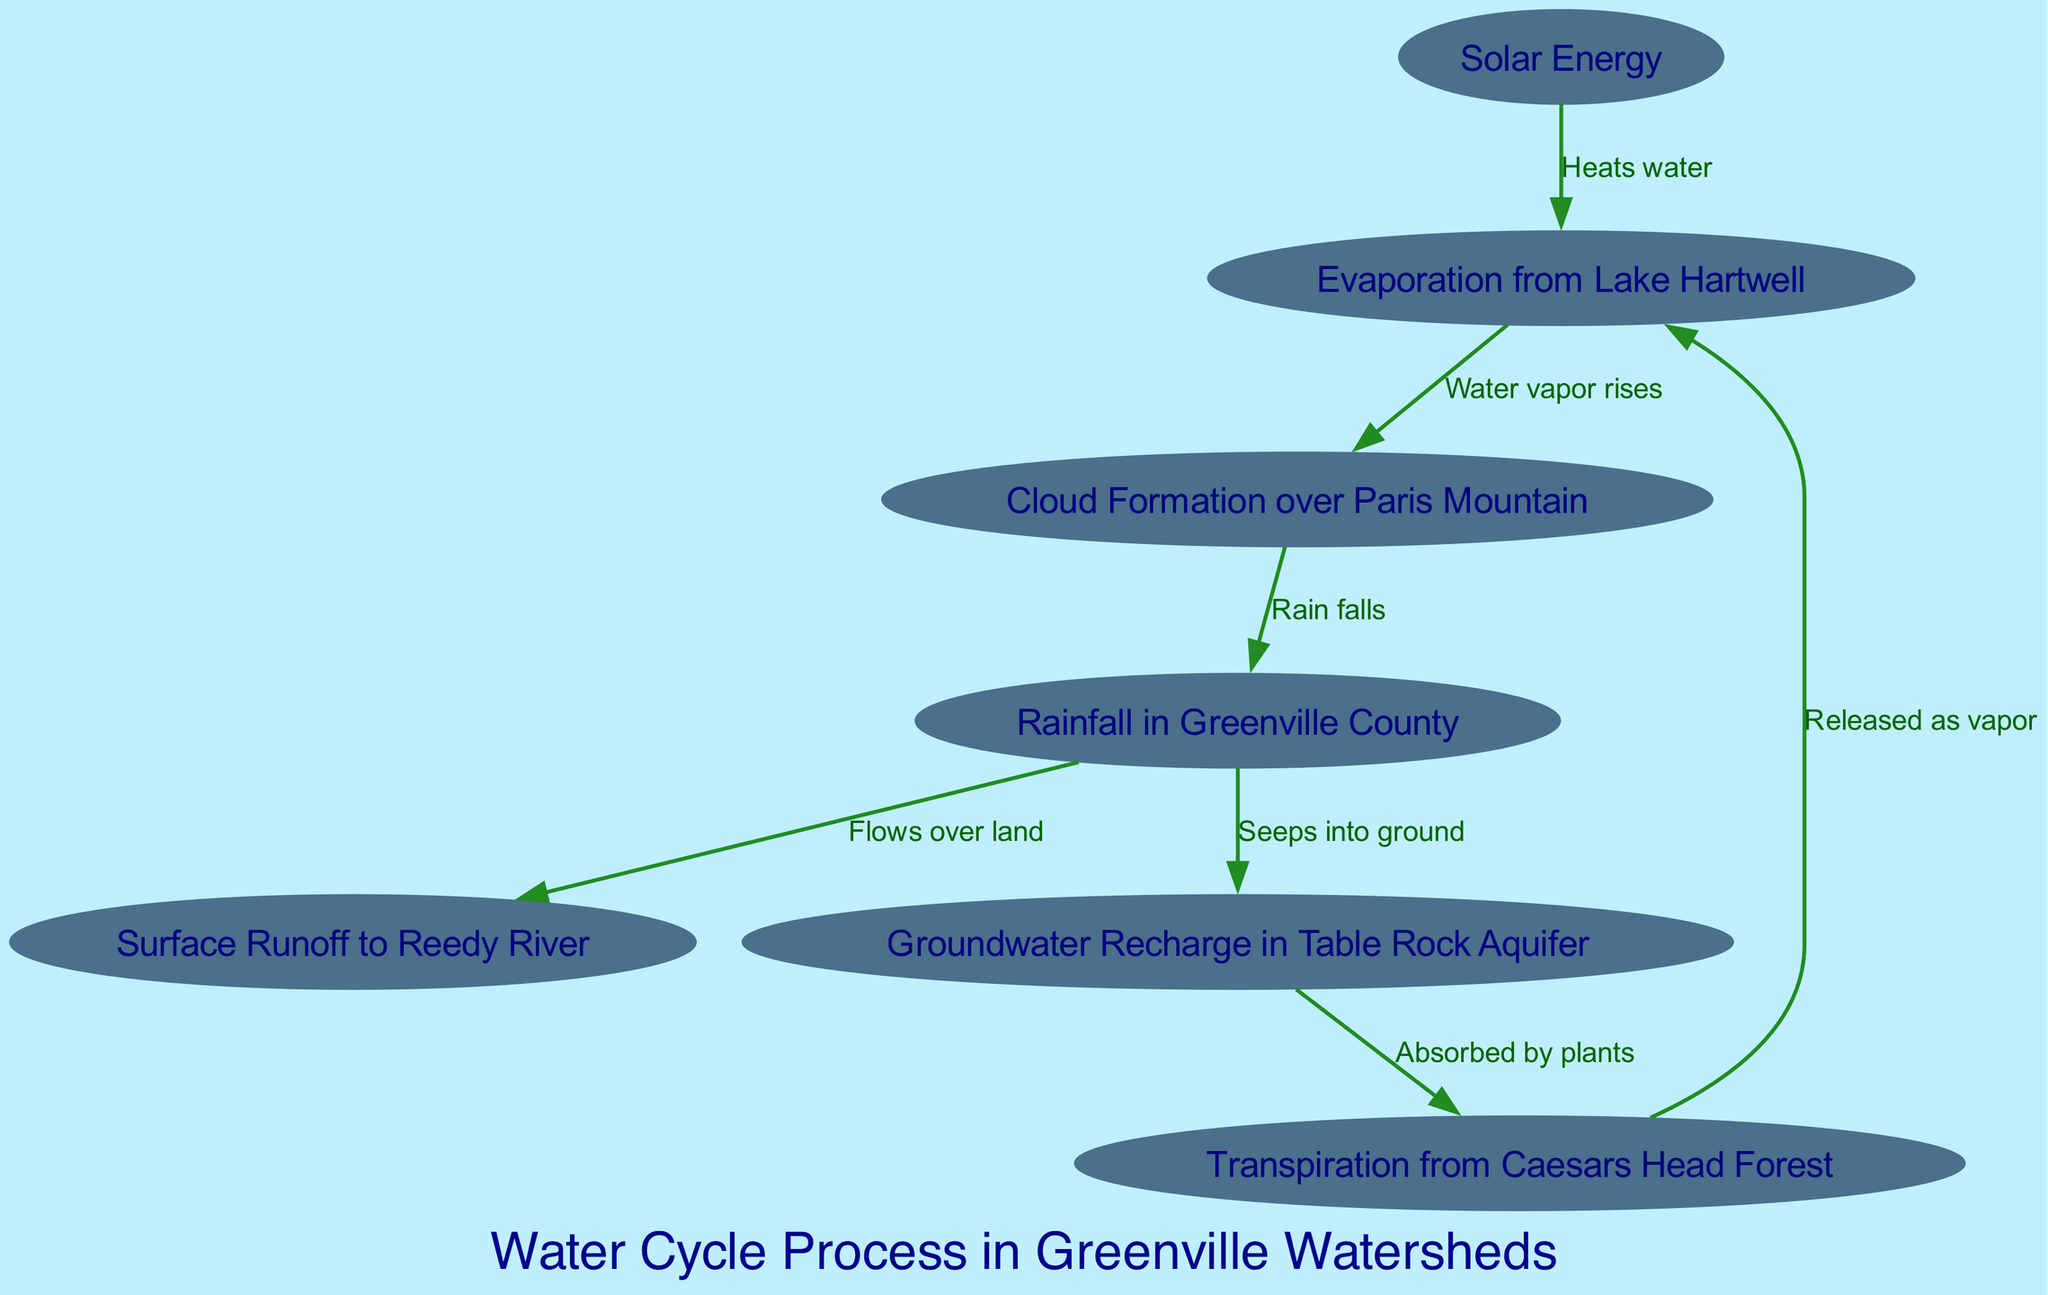What is the first process in the water cycle? The diagram illustrates that the first process is triggered by solar energy, which heats the water and initiates evaporation. Therefore, by following the flow from sunlight, we identify that evaporation is the first step.
Answer: Evaporation from Lake Hartwell How many nodes are in the diagram? To determine the total number of nodes, we can count each unique process represented in the diagram. The nodes include solar energy, evaporation, condensation, precipitation, runoff, infiltration, and transpiration, which gives us a total of seven nodes.
Answer: 7 What process comes after cloud formation? Following the diagram’s flow, we see that after condensation (cloud formation), the next step is precipitation where rain falls. This is indicated by the directed connection from condensation to precipitation.
Answer: Rainfall in Greenville County What process occurs due to precipitation before infiltration? The diagram indicates that after precipitation, surface runoff occurs where the rainfall flows over land before any infiltration can take place. This is shown by the edge leading from precipitation to runoff.
Answer: Surface Runoff to Reedy River Which watershed receives rainfall according to the diagram? The process of precipitation in the diagram specifically notes that rainfall occurs in Greenville County. Hence, it directly identifies the watershed that receives rainfall.
Answer: Rainfall in Greenville County From which process is ground water recharge derived? The diagram shows that groundwater recharge is a result of infiltration, where precipitation seeps into the ground. Analyzing the directed edges indicates that infiltration is derived from precipitation.
Answer: Groundwater Recharge in Table Rock Aquifer How does transpiration relate to evaporation in the cycle? The diagram indicates that transpiration is connected back to evaporation, illustrating a cyclical process where moisture released from plants is ultimately returned to the atmosphere as vapor, thus rekindling the evaporation phase.
Answer: Released as vapor What is the final process in the water cycle before it starts over? By tracing the flow of the diagram, we find that after transpiration, the cycle loops back to evaporation. This cyclical nature shows how the processes continuously interact.
Answer: Evaporation from Lake Hartwell 